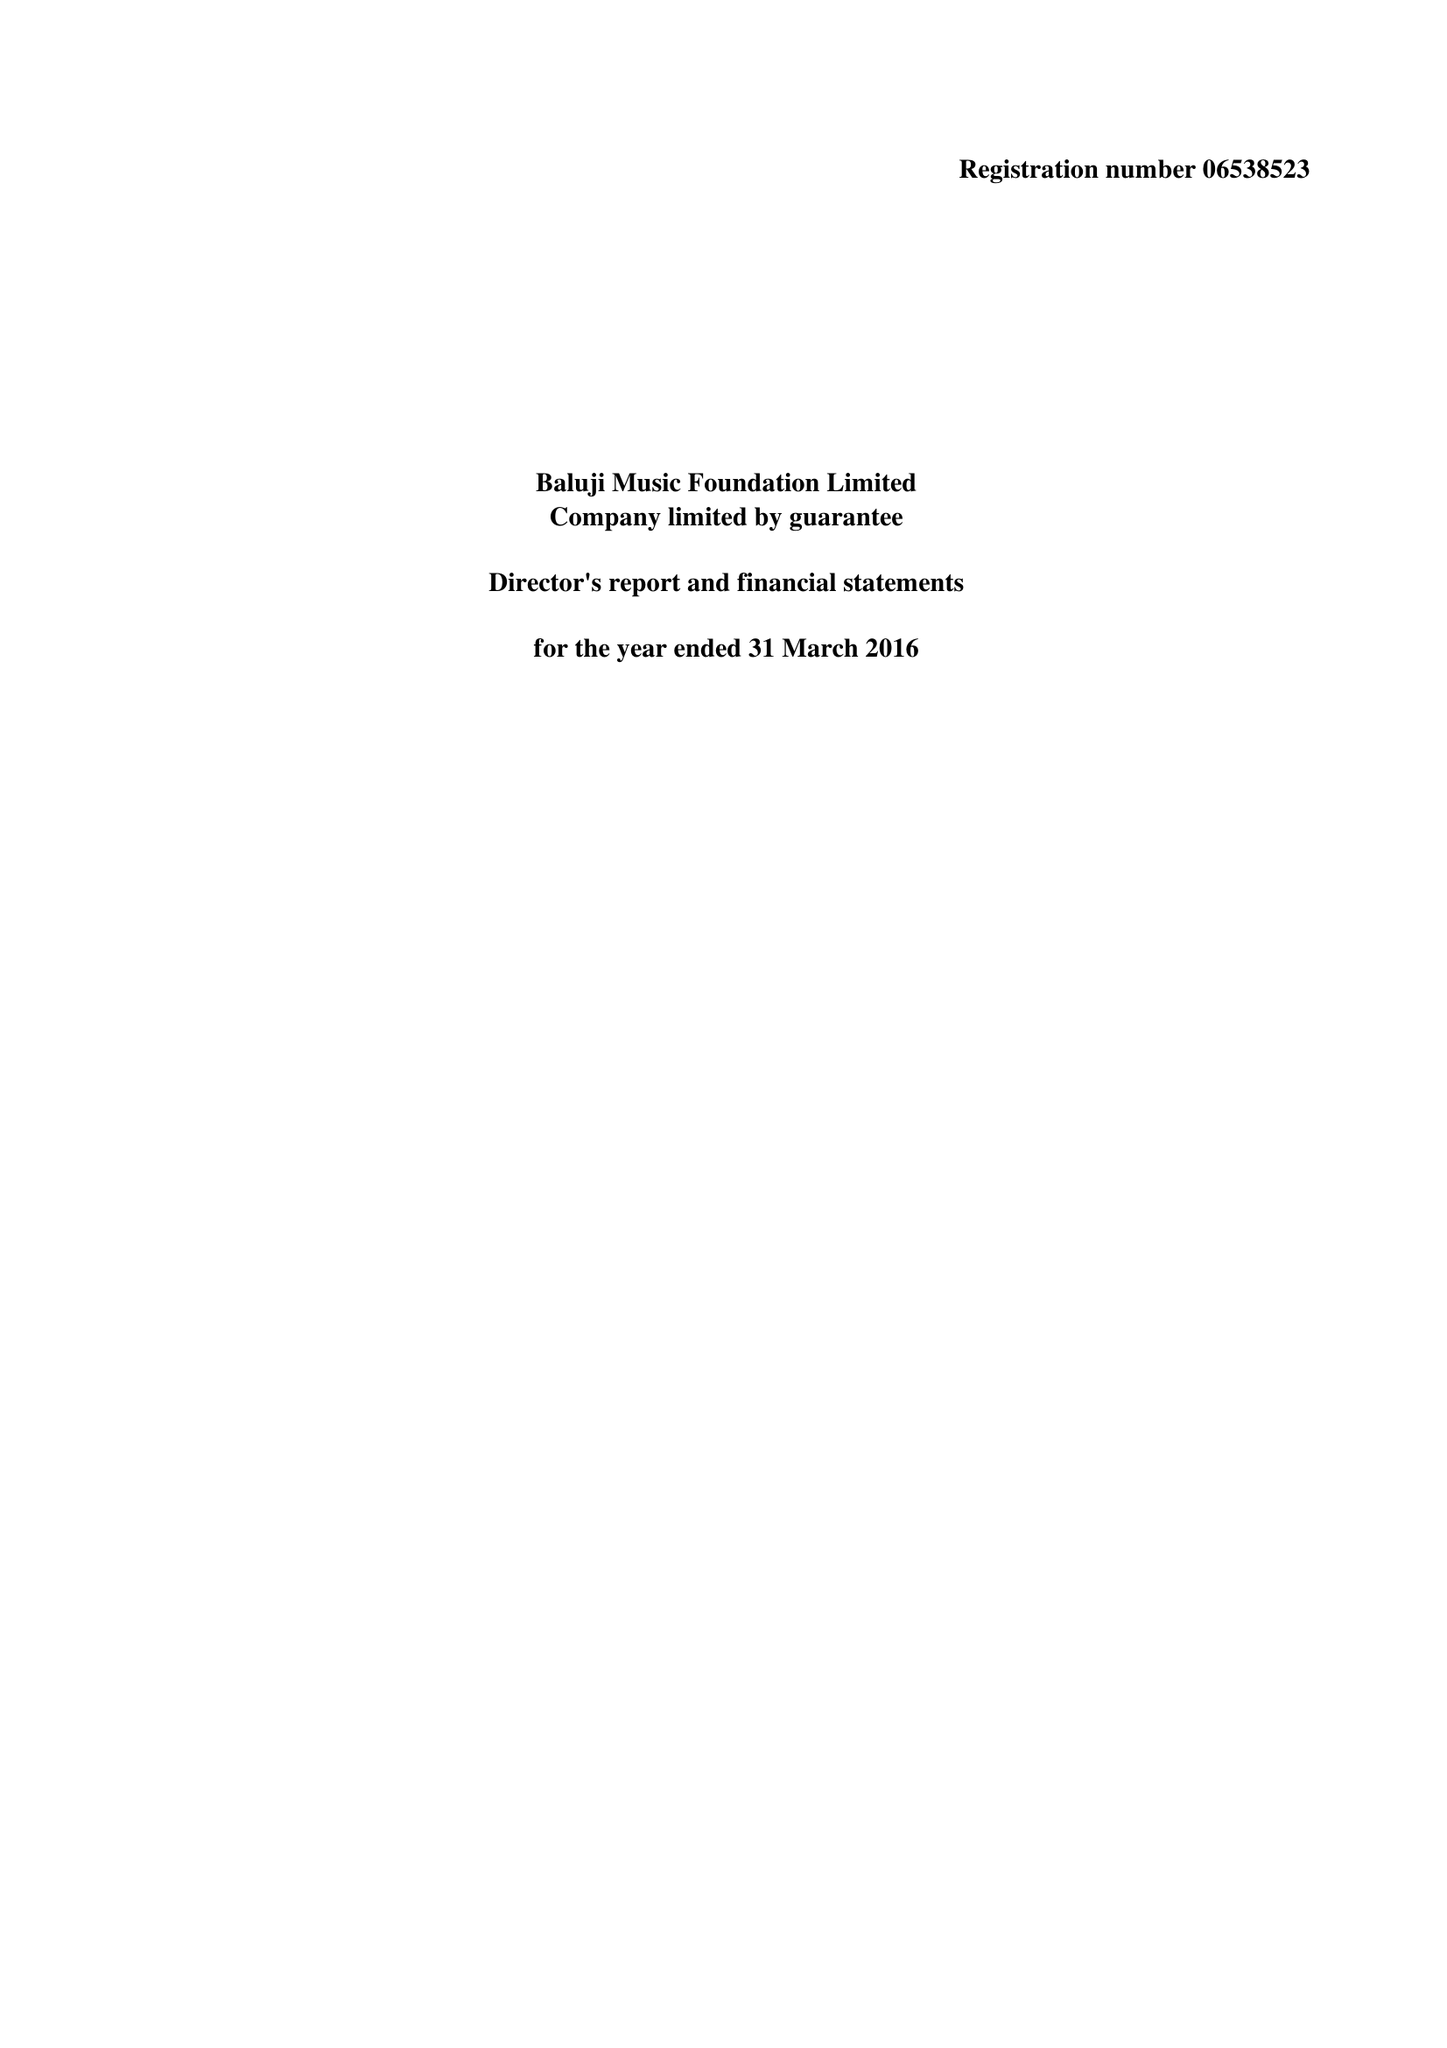What is the value for the spending_annually_in_british_pounds?
Answer the question using a single word or phrase. 27995.00 